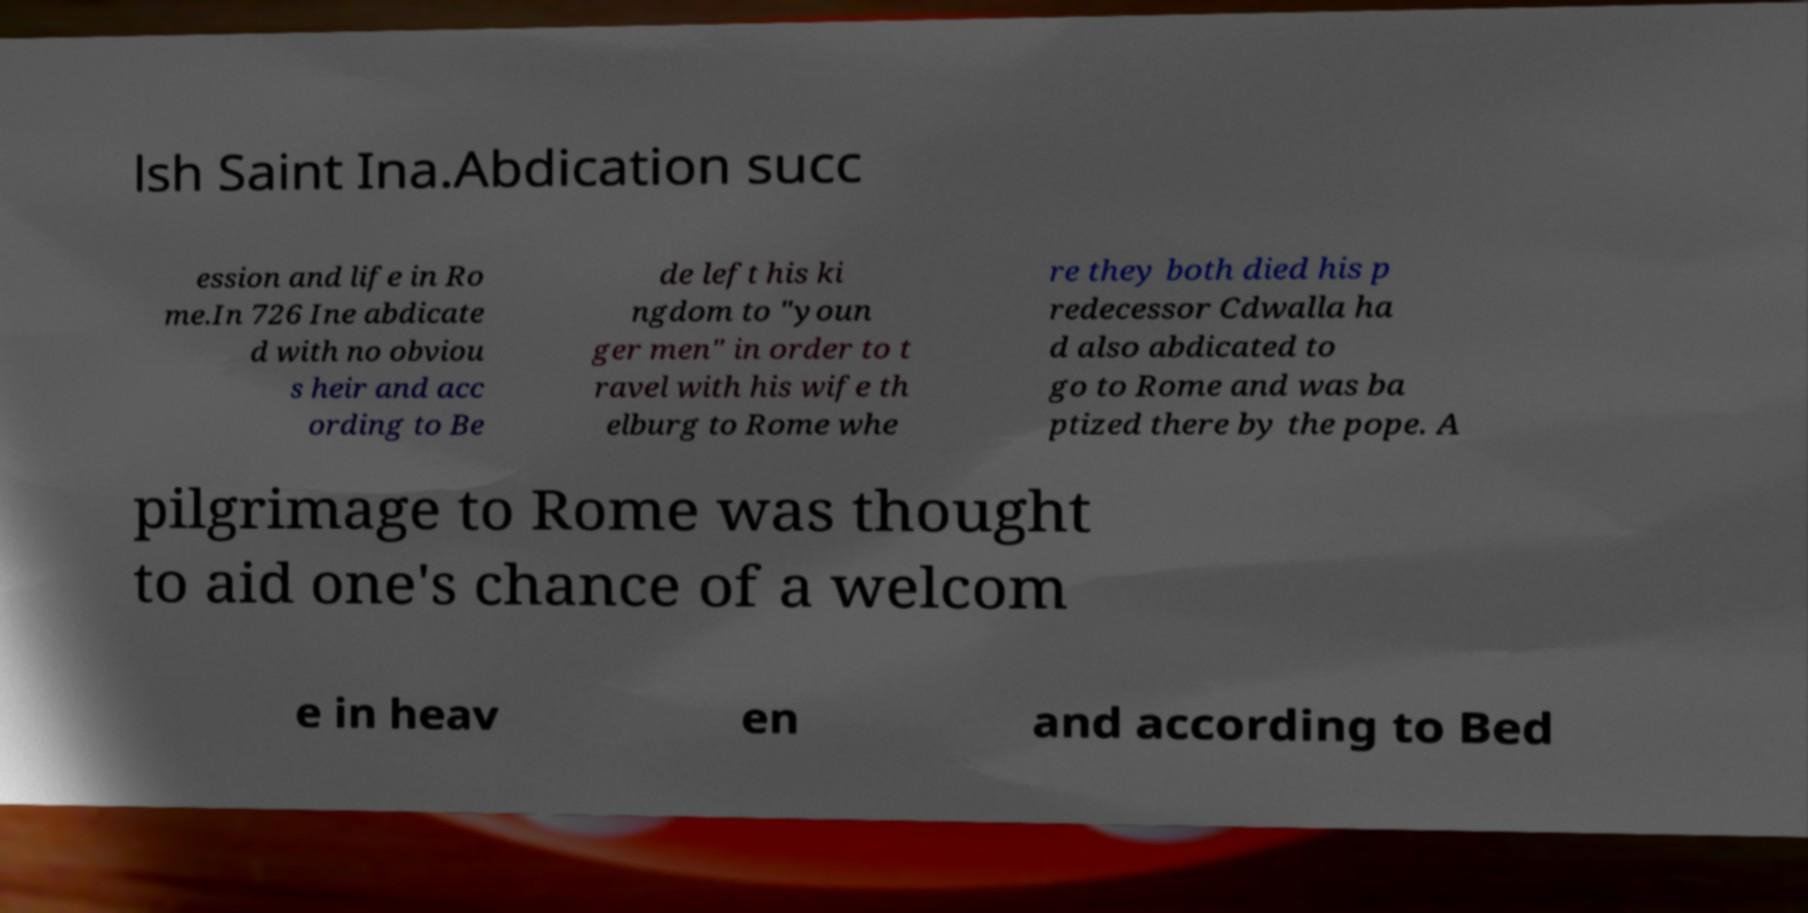Please identify and transcribe the text found in this image. lsh Saint Ina.Abdication succ ession and life in Ro me.In 726 Ine abdicate d with no obviou s heir and acc ording to Be de left his ki ngdom to "youn ger men" in order to t ravel with his wife th elburg to Rome whe re they both died his p redecessor Cdwalla ha d also abdicated to go to Rome and was ba ptized there by the pope. A pilgrimage to Rome was thought to aid one's chance of a welcom e in heav en and according to Bed 